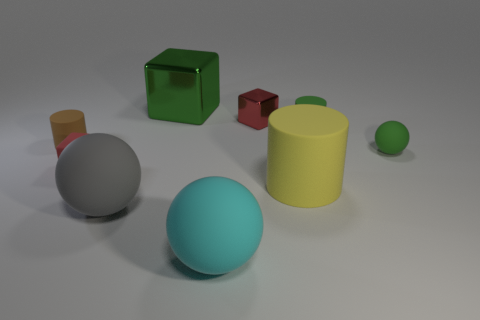Add 1 tiny yellow shiny blocks. How many objects exist? 10 Subtract all balls. How many objects are left? 6 Subtract 2 red cubes. How many objects are left? 7 Subtract all red rubber cubes. Subtract all green rubber blocks. How many objects are left? 8 Add 3 large cubes. How many large cubes are left? 4 Add 1 big brown rubber balls. How many big brown rubber balls exist? 1 